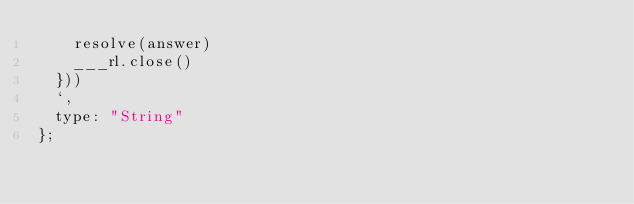<code> <loc_0><loc_0><loc_500><loc_500><_JavaScript_>    resolve(answer)
    ___rl.close()
  }))
  `,
  type: "String"
};
</code> 